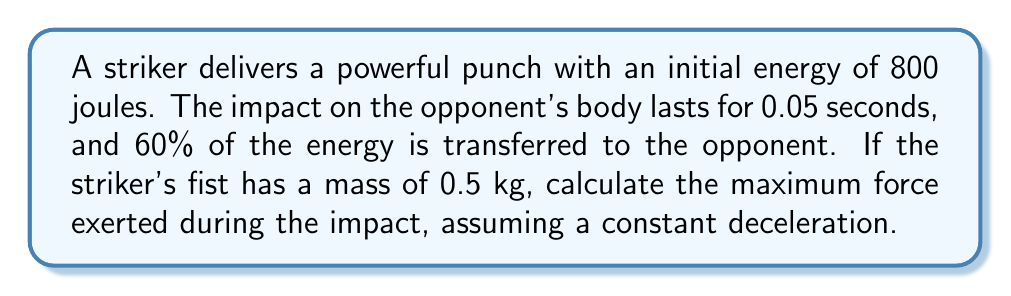Help me with this question. To solve this problem, we'll use concepts from impact mechanics and energy transfer. Let's break it down step-by-step:

1) First, we need to determine the energy transferred to the opponent:
   $E_{transferred} = 60\% \text{ of } 800 \text{ J} = 0.6 \times 800 \text{ J} = 480 \text{ J}$

2) The work done during the impact is equal to the energy transferred:
   $W = E_{transferred} = 480 \text{ J}$

3) Work is also equal to the average force multiplied by the displacement:
   $W = F_{avg} \times d$

4) We don't know the displacement, but we can use the work-energy theorem to find the change in velocity:
   $W = \frac{1}{2}mv^2 - \frac{1}{2}mv_0^2$

   Where $v$ is the final velocity (0 m/s, as the fist stops) and $v_0$ is the initial velocity.

5) Rearranging this equation:
   $480 = \frac{1}{2}(0.5)(0^2) - \frac{1}{2}(0.5)v_0^2$
   $480 = -0.25v_0^2$
   $v_0^2 = -1920$
   $v_0 = \sqrt{1920} = 43.82 \text{ m/s}$

6) Now we can use the equation for constant acceleration:
   $v = v_0 + at$
   $0 = 43.82 + a(0.05)$
   $a = -876.4 \text{ m/s}^2$

7) Finally, we can use Newton's Second Law to find the maximum force:
   $F_{max} = ma = 0.5 \times 876.4 = 438.2 \text{ N}$

Therefore, the maximum force exerted during the impact is approximately 438.2 N.
Answer: $438.2 \text{ N}$ 